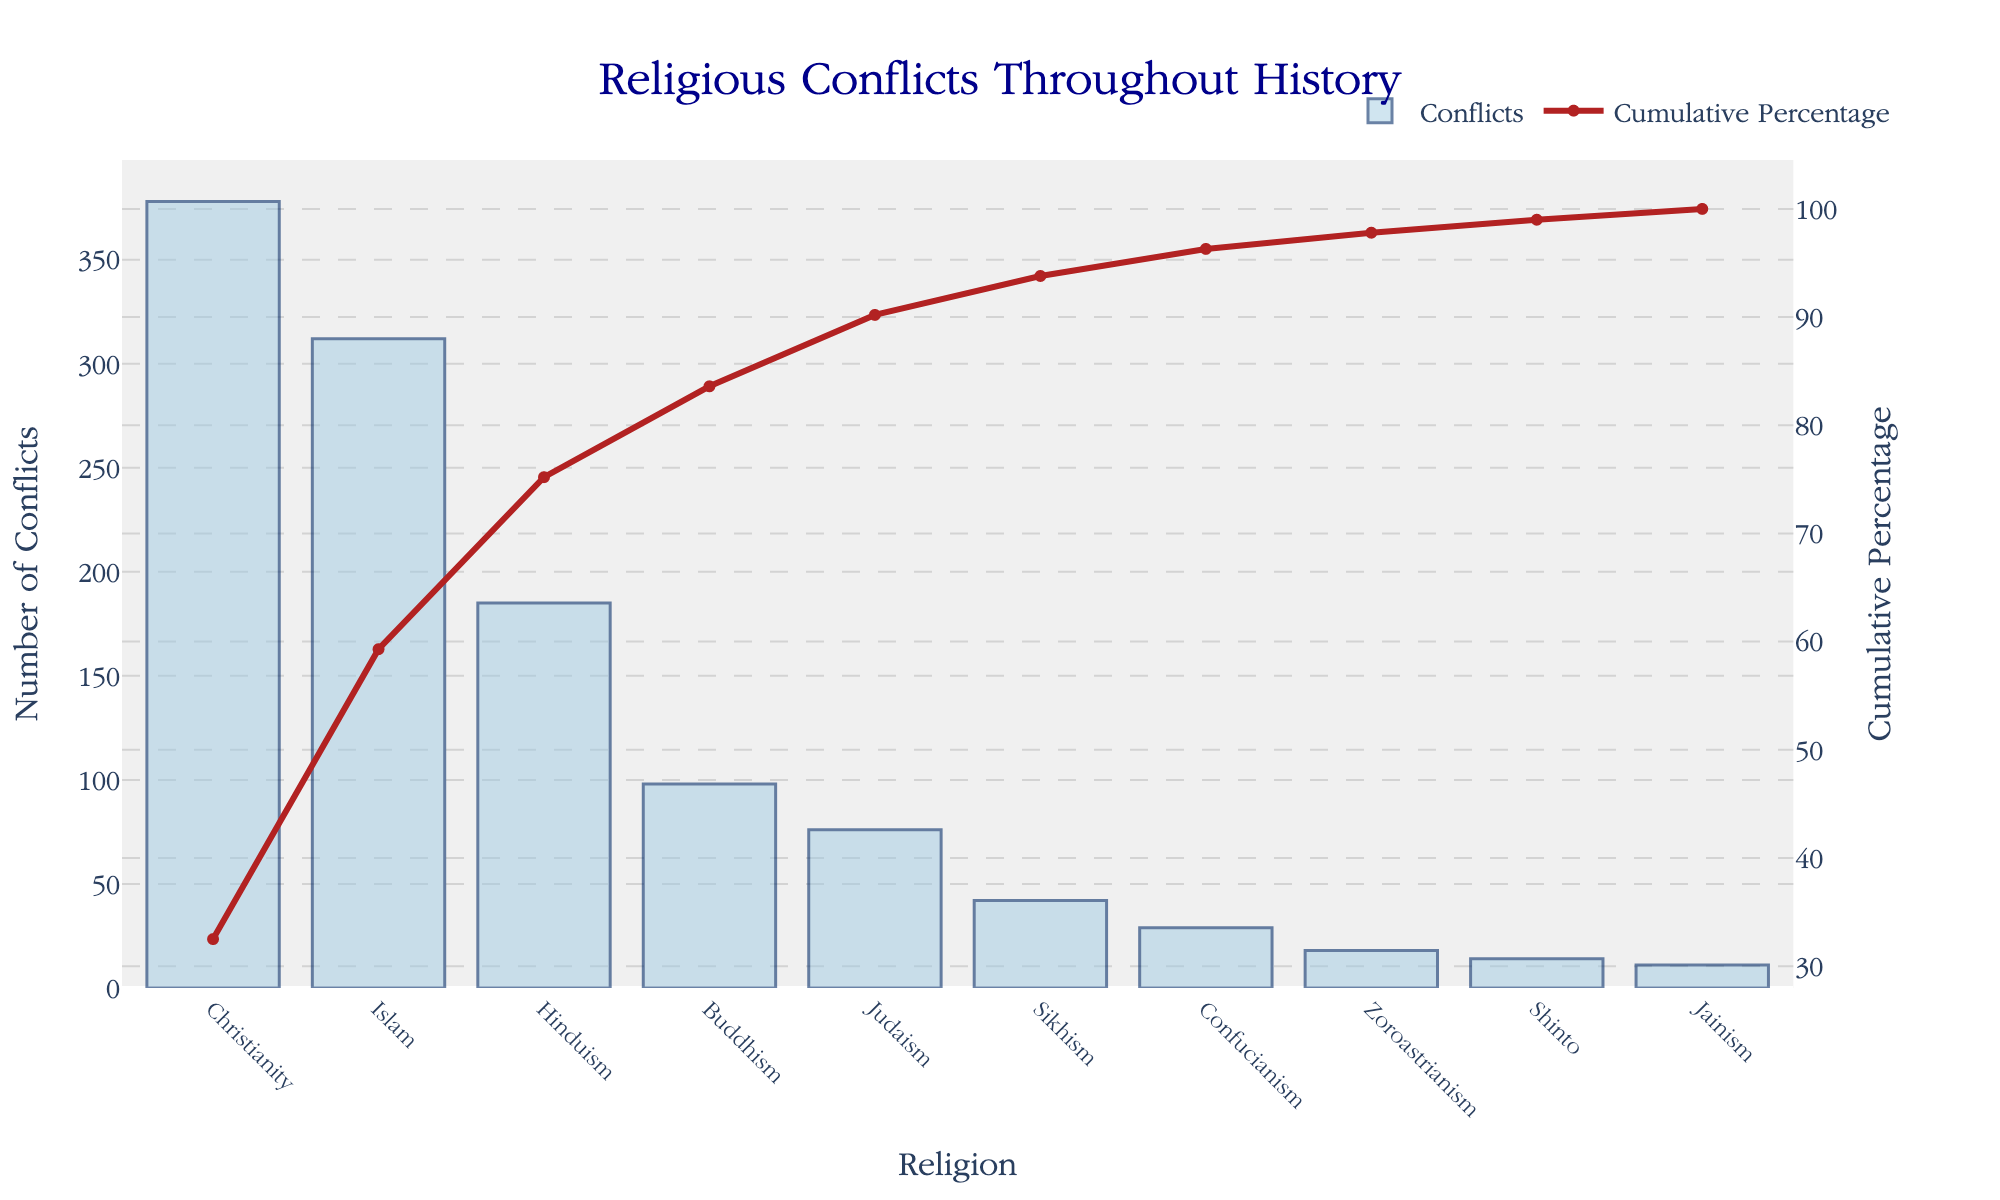What's the title of the figure? The title is usually placed at the top center of the figure. Here, it states "Religious Conflicts Throughout History".
Answer: Religious Conflicts Throughout History Which religion has the highest number of conflicts? To find the religion with the highest number, look at the tallest bar in the figure. Here, it's Christianity.
Answer: Christianity What is the cumulative percentage after accounting for conflicts associated with Christianity and Islam? Locate Christianity and Islam in the cumulative percentage line graph and sum their values. Christianity has 32.5% and Islam has 59.3%, so their cumulative percentage is 59.3%.
Answer: 59.3% How many conflicts were associated with Judaism? Find the bar labeled Judaism and read its height value, which is 76 conflicts.
Answer: 76 Which religion has the lowest number of conflicts? To identify this, find the shortest bar on the chart. Jainism is the shortest bar at 11 conflicts.
Answer: Jainism By how much does the number of conflicts associated with Islam exceed those associated with Buddhism? Deduct the number of conflicts in Buddhism (98) from those in Islam (312). The difference is 312 - 98 = 214.
Answer: 214 What percentage of total conflicts are accounted for after including conflicts from Buddhism? Sum up Christianity (32.5%), Islam (59.3%), Hinduism (75.2%), and Buddhism (83.6%) to get 83.6%.
Answer: 83.6% Compare the conflicts of Sikhism and Confucianism in terms of their cumulative percentage contributions. Look at the percentages for Sikhism and Confucianism on the cumulative percentage line. Sikhism contributes to 93.8% and Confucianism to 96.3%.
Answer: Sikhism: 93.8%, Confucianism: 96.3% What is the color of the bar representing the number of conflicts? Based on the visual description, the bar color would be light blue with dark blue borders.
Answer: Light blue If considering only the top three religions by the number of conflicts, what is their total cumulative percentage? Sum the cumulative percentages of Christianity (32.5%), Islam (59.3%), and Hinduism (75.2%), to get 75.2%.
Answer: 75.2% 